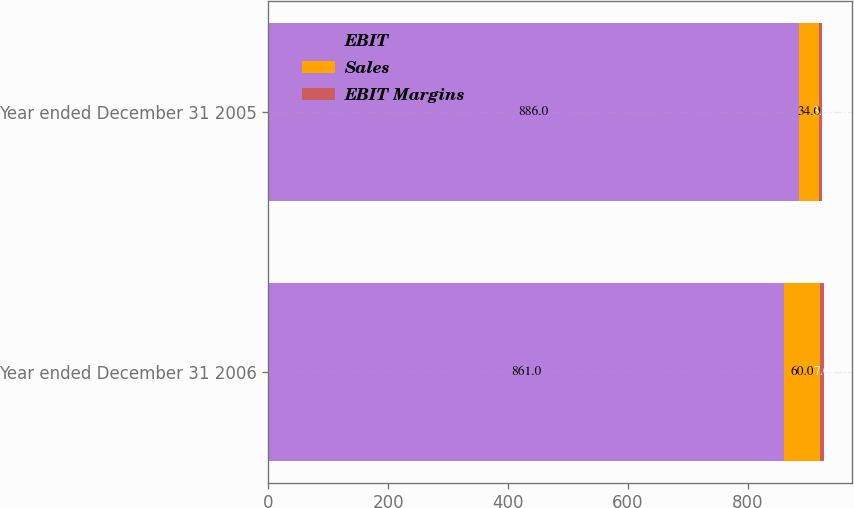Convert chart. <chart><loc_0><loc_0><loc_500><loc_500><stacked_bar_chart><ecel><fcel>Year ended December 31 2006<fcel>Year ended December 31 2005<nl><fcel>EBIT<fcel>861<fcel>886<nl><fcel>Sales<fcel>60<fcel>34<nl><fcel>EBIT Margins<fcel>7<fcel>3.9<nl></chart> 